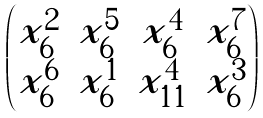<formula> <loc_0><loc_0><loc_500><loc_500>\begin{pmatrix} x _ { 6 } ^ { 2 } & x _ { 6 } ^ { 5 } & x _ { 6 } ^ { 4 } & x _ { 6 } ^ { 7 } \\ x _ { 6 } ^ { 6 } & x _ { 6 } ^ { 1 } & x _ { 1 1 } ^ { 4 } & x _ { 6 } ^ { 3 } \end{pmatrix}</formula> 